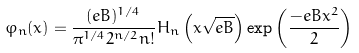Convert formula to latex. <formula><loc_0><loc_0><loc_500><loc_500>\varphi _ { n } ( x ) = \frac { ( e B ) ^ { 1 / 4 } } { \pi ^ { 1 / 4 } 2 ^ { n / 2 } n ! } H _ { n } \left ( x \sqrt { e B } \right ) \exp \left ( \frac { - e B x ^ { 2 } } { 2 } \right )</formula> 